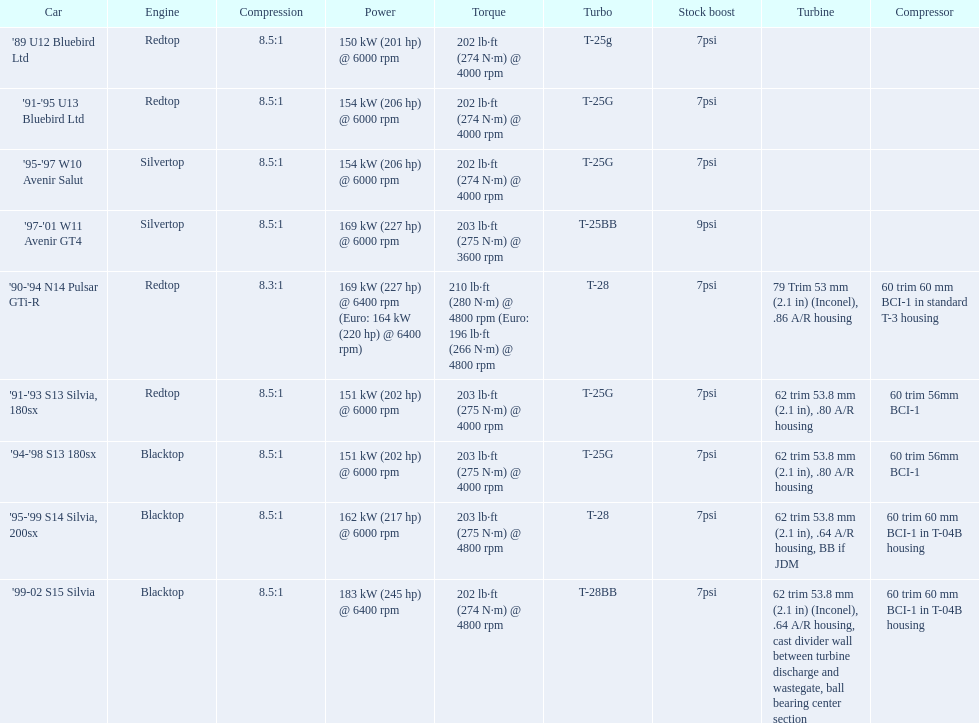Which engines share similarities with the first entry ('89 u12 bluebird ltd)? '91-'95 U13 Bluebird Ltd, '90-'94 N14 Pulsar GTi-R, '91-'93 S13 Silvia, 180sx. 